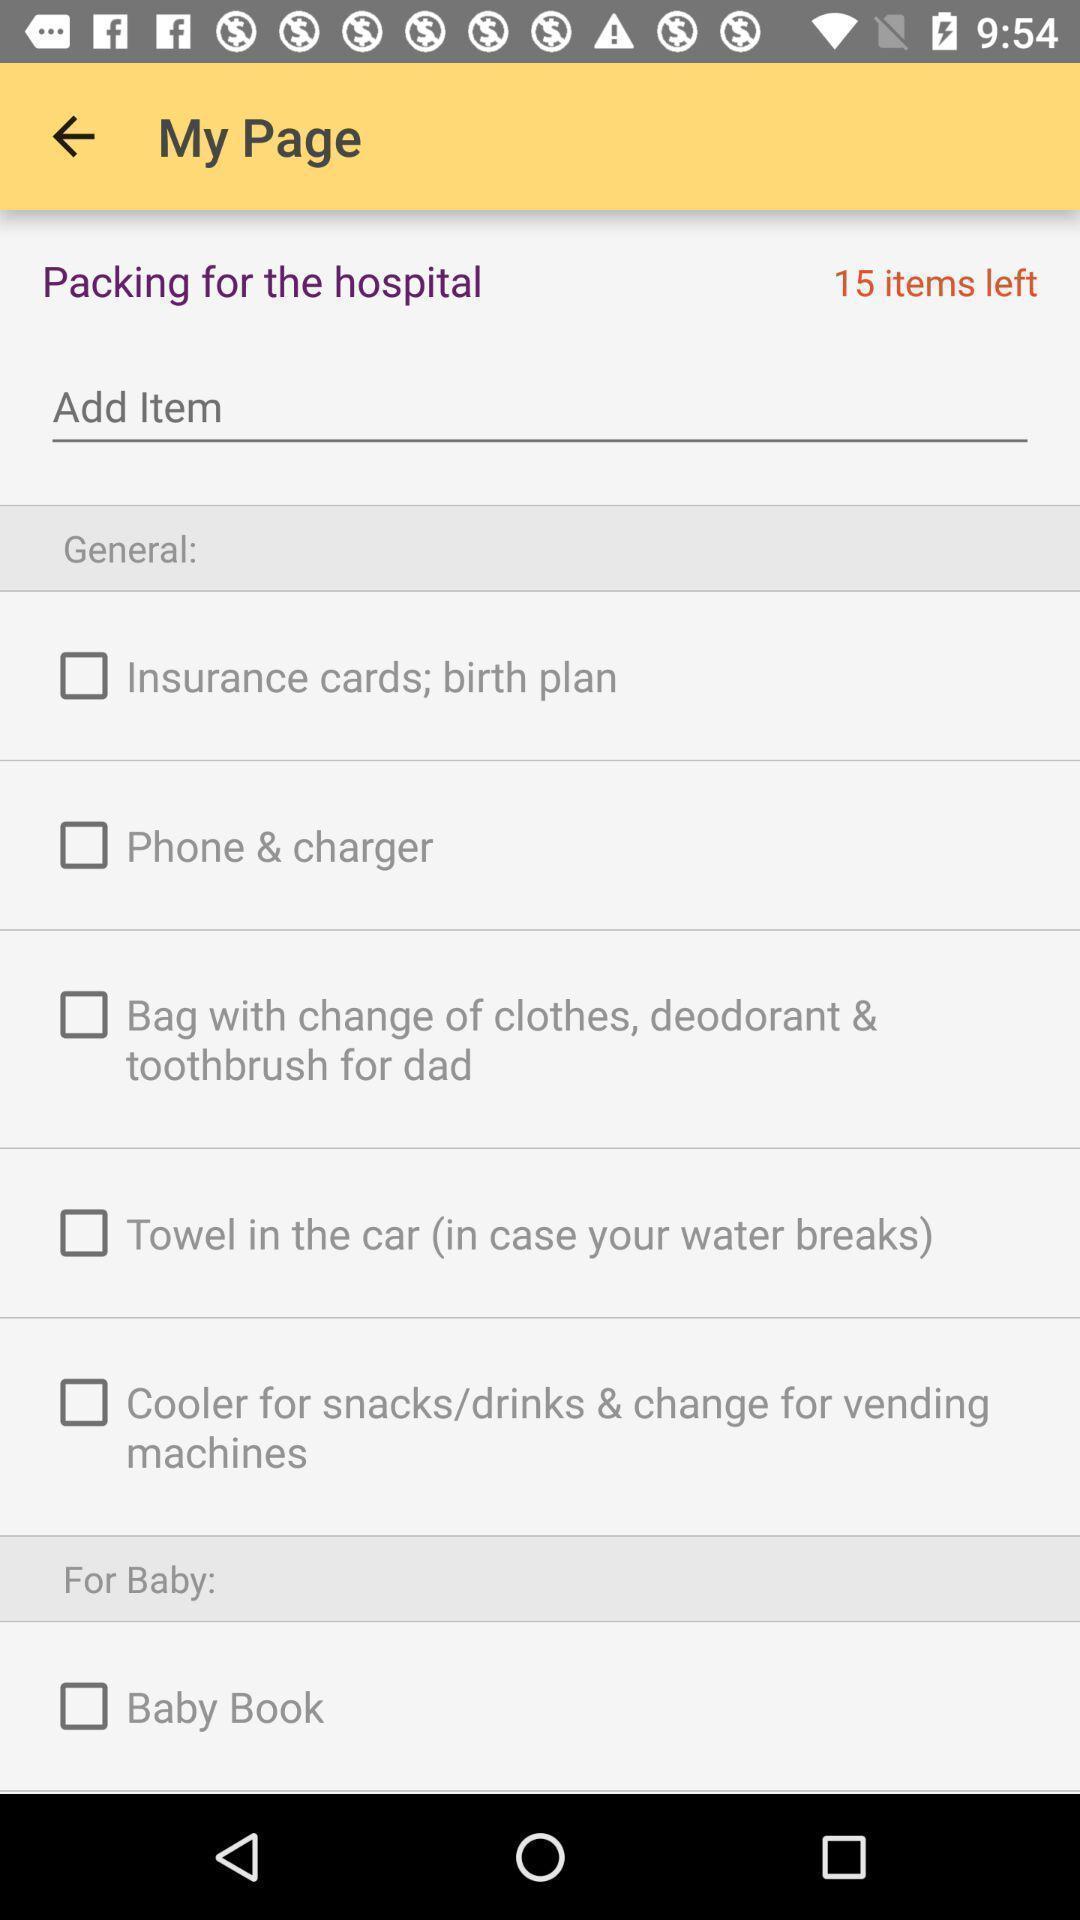Explain what's happening in this screen capture. Page of a health care services app. 